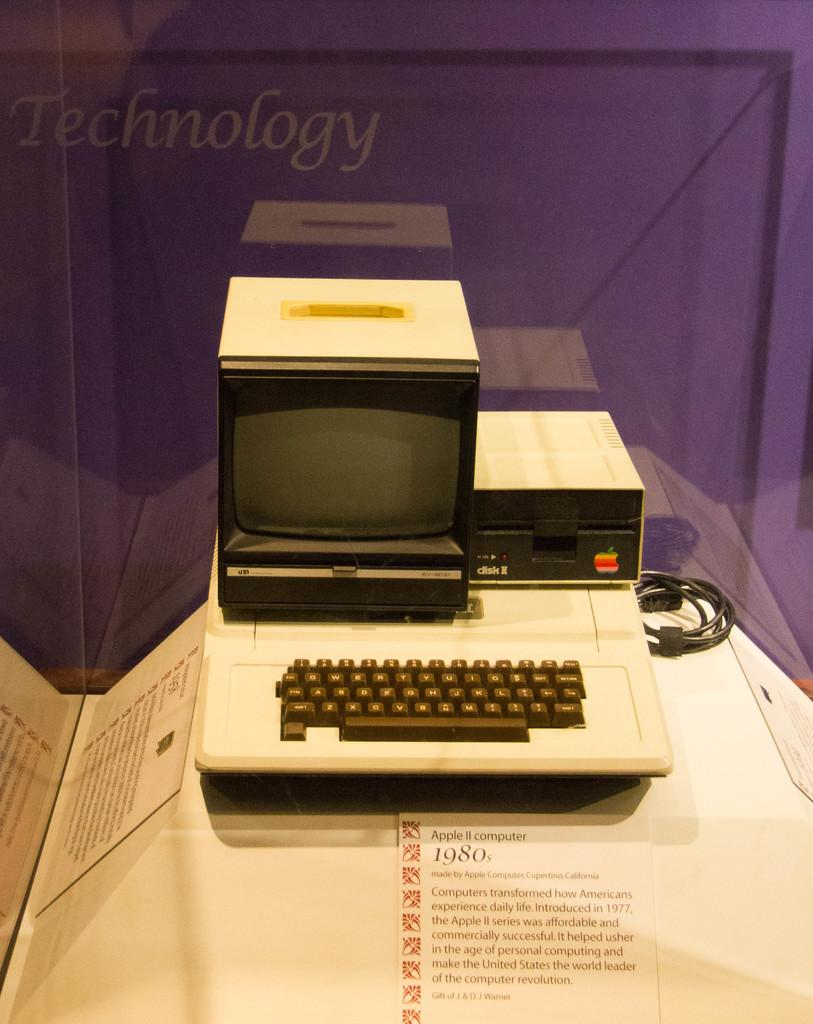<image>
Describe the image concisely. An Apple II computer from the 1980s is on display in front of a purple wall. 